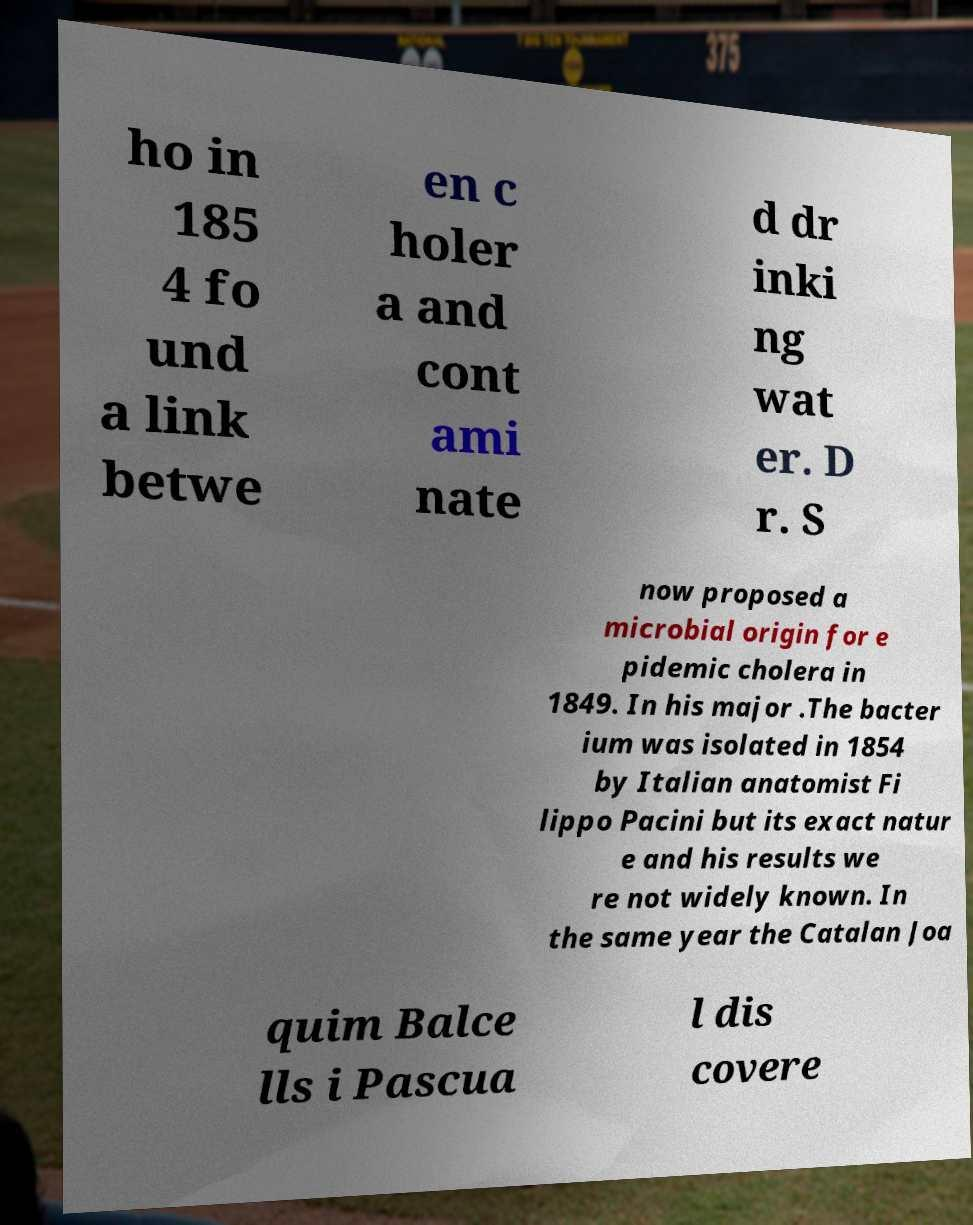Could you extract and type out the text from this image? ho in 185 4 fo und a link betwe en c holer a and cont ami nate d dr inki ng wat er. D r. S now proposed a microbial origin for e pidemic cholera in 1849. In his major .The bacter ium was isolated in 1854 by Italian anatomist Fi lippo Pacini but its exact natur e and his results we re not widely known. In the same year the Catalan Joa quim Balce lls i Pascua l dis covere 